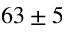<formula> <loc_0><loc_0><loc_500><loc_500>6 3 \pm 5</formula> 